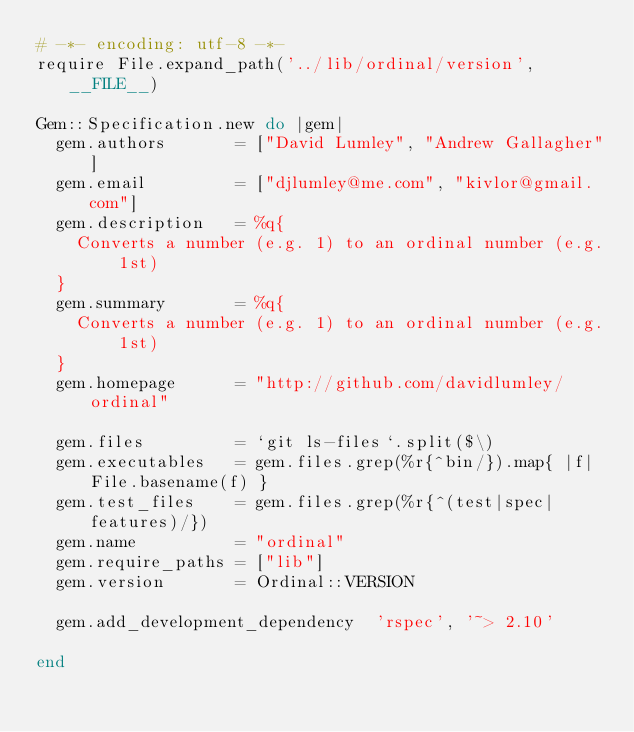<code> <loc_0><loc_0><loc_500><loc_500><_Ruby_># -*- encoding: utf-8 -*-
require File.expand_path('../lib/ordinal/version', __FILE__)

Gem::Specification.new do |gem|
  gem.authors       = ["David Lumley", "Andrew Gallagher"]
  gem.email         = ["djlumley@me.com", "kivlor@gmail.com"]
  gem.description   = %q{
    Converts a number (e.g. 1) to an ordinal number (e.g. 1st)
  }
  gem.summary       = %q{
    Converts a number (e.g. 1) to an ordinal number (e.g. 1st)
  }
  gem.homepage      = "http://github.com/davidlumley/ordinal"

  gem.files         = `git ls-files`.split($\)
  gem.executables   = gem.files.grep(%r{^bin/}).map{ |f| File.basename(f) }
  gem.test_files    = gem.files.grep(%r{^(test|spec|features)/})
  gem.name          = "ordinal"
  gem.require_paths = ["lib"]
  gem.version       = Ordinal::VERSION
  
  gem.add_development_dependency  'rspec', '~> 2.10'
  
end
</code> 